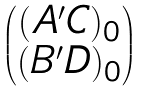Convert formula to latex. <formula><loc_0><loc_0><loc_500><loc_500>\begin{pmatrix} ( A ^ { \prime } C ) _ { 0 } \\ ( B ^ { \prime } D ) _ { 0 } \end{pmatrix}</formula> 